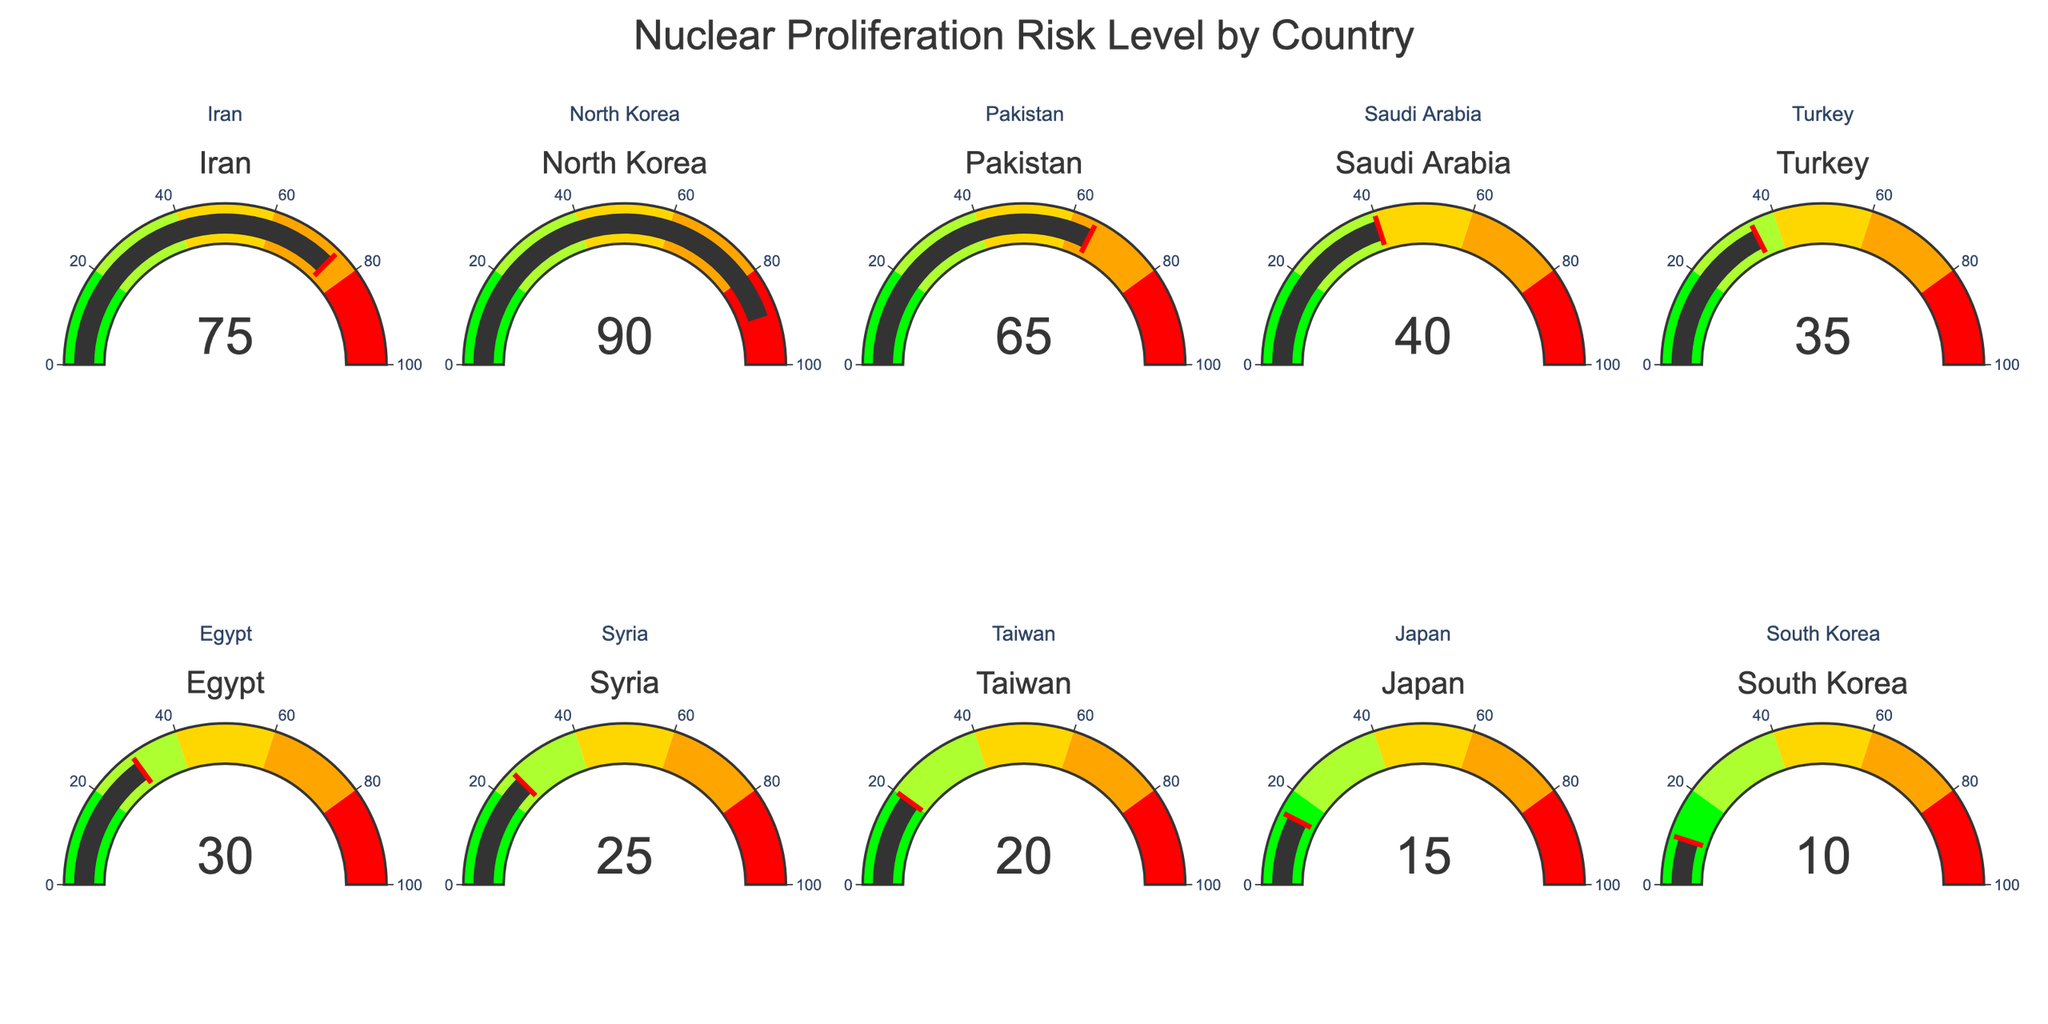what is the nuclear proliferation risk level for North Korea? Locate the gauge labelled "North Korea" and observe the number displayed in the gauge.
Answer: 90 Which country has the lowest nuclear proliferation risk level? Identify the gauge with the smallest number.
Answer: South Korea What is the difference in nuclear proliferation risk between Iran and Saudi Arabia? Find the values for Iran (75) and Saudi Arabia (40) and subtract the latter from the former: 75 - 40.
Answer: 35 Is there any country with a nuclear proliferation risk level greater than 80? Check all gauges for numbers greater than 80.
Answer: Yes, North Korea What is the average nuclear proliferation risk level of the countries listed? Sum each country's risk level and divide by the number of countries: (75 + 90 + 65 + 40 + 35 + 30 + 25 + 20 + 15 + 10) / 10 = 40
Answer: 40 Which country has a higher nuclear proliferation risk level: Pakistan or Egypt? Compare the values for Pakistan (65) and Egypt (30).
Answer: Pakistan How many countries have a nuclear proliferation risk level less than 50? Count the gauges with numbers less than 50: Saudi Arabia, Turkey, Egypt, Syria, Taiwan, Japan, South Korea.
Answer: 7 What is the range of nuclear proliferation risk levels in the data? Subtract the lowest value (10, South Korea) from the highest value (90, North Korea): 90 - 10.
Answer: 80 Is the nuclear proliferation risk level for Japan higher than for Taiwan? Compare the values for Japan (15) and Taiwan (20).
Answer: No 